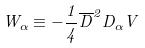<formula> <loc_0><loc_0><loc_500><loc_500>W _ { \alpha } \equiv - \frac { 1 } { 4 } \overline { D } ^ { 2 } D _ { \alpha } V</formula> 